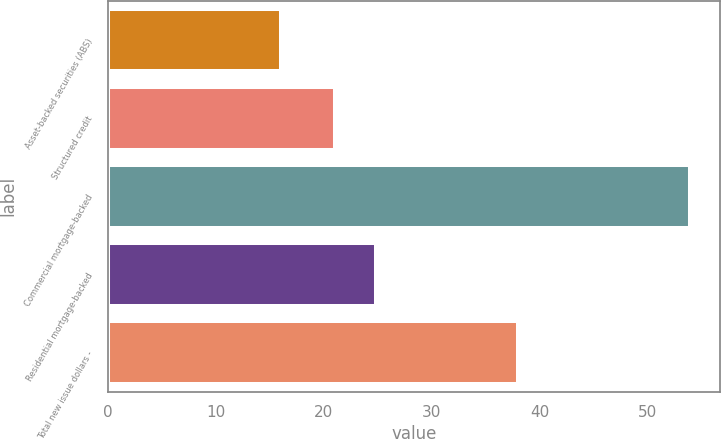Convert chart to OTSL. <chart><loc_0><loc_0><loc_500><loc_500><bar_chart><fcel>Asset-backed securities (ABS)<fcel>Structured credit<fcel>Commercial mortgage-backed<fcel>Residential mortgage-backed<fcel>Total new issue dollars -<nl><fcel>16<fcel>21<fcel>54<fcel>24.8<fcel>38<nl></chart> 